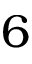<formula> <loc_0><loc_0><loc_500><loc_500>6</formula> 